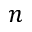Convert formula to latex. <formula><loc_0><loc_0><loc_500><loc_500>n</formula> 